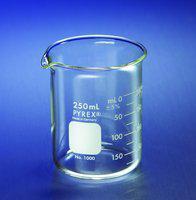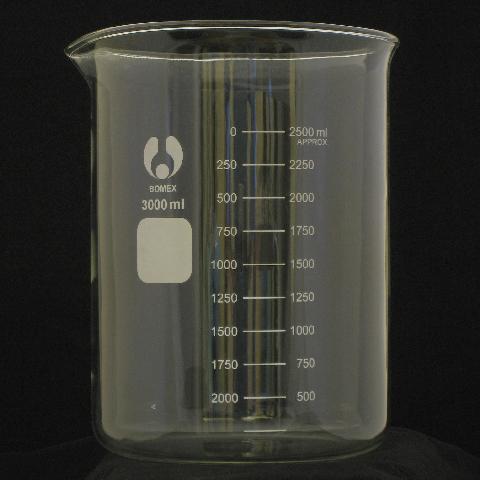The first image is the image on the left, the second image is the image on the right. Assess this claim about the two images: "There is no less than one clear beaker filled with a blue liquid". Correct or not? Answer yes or no. No. 